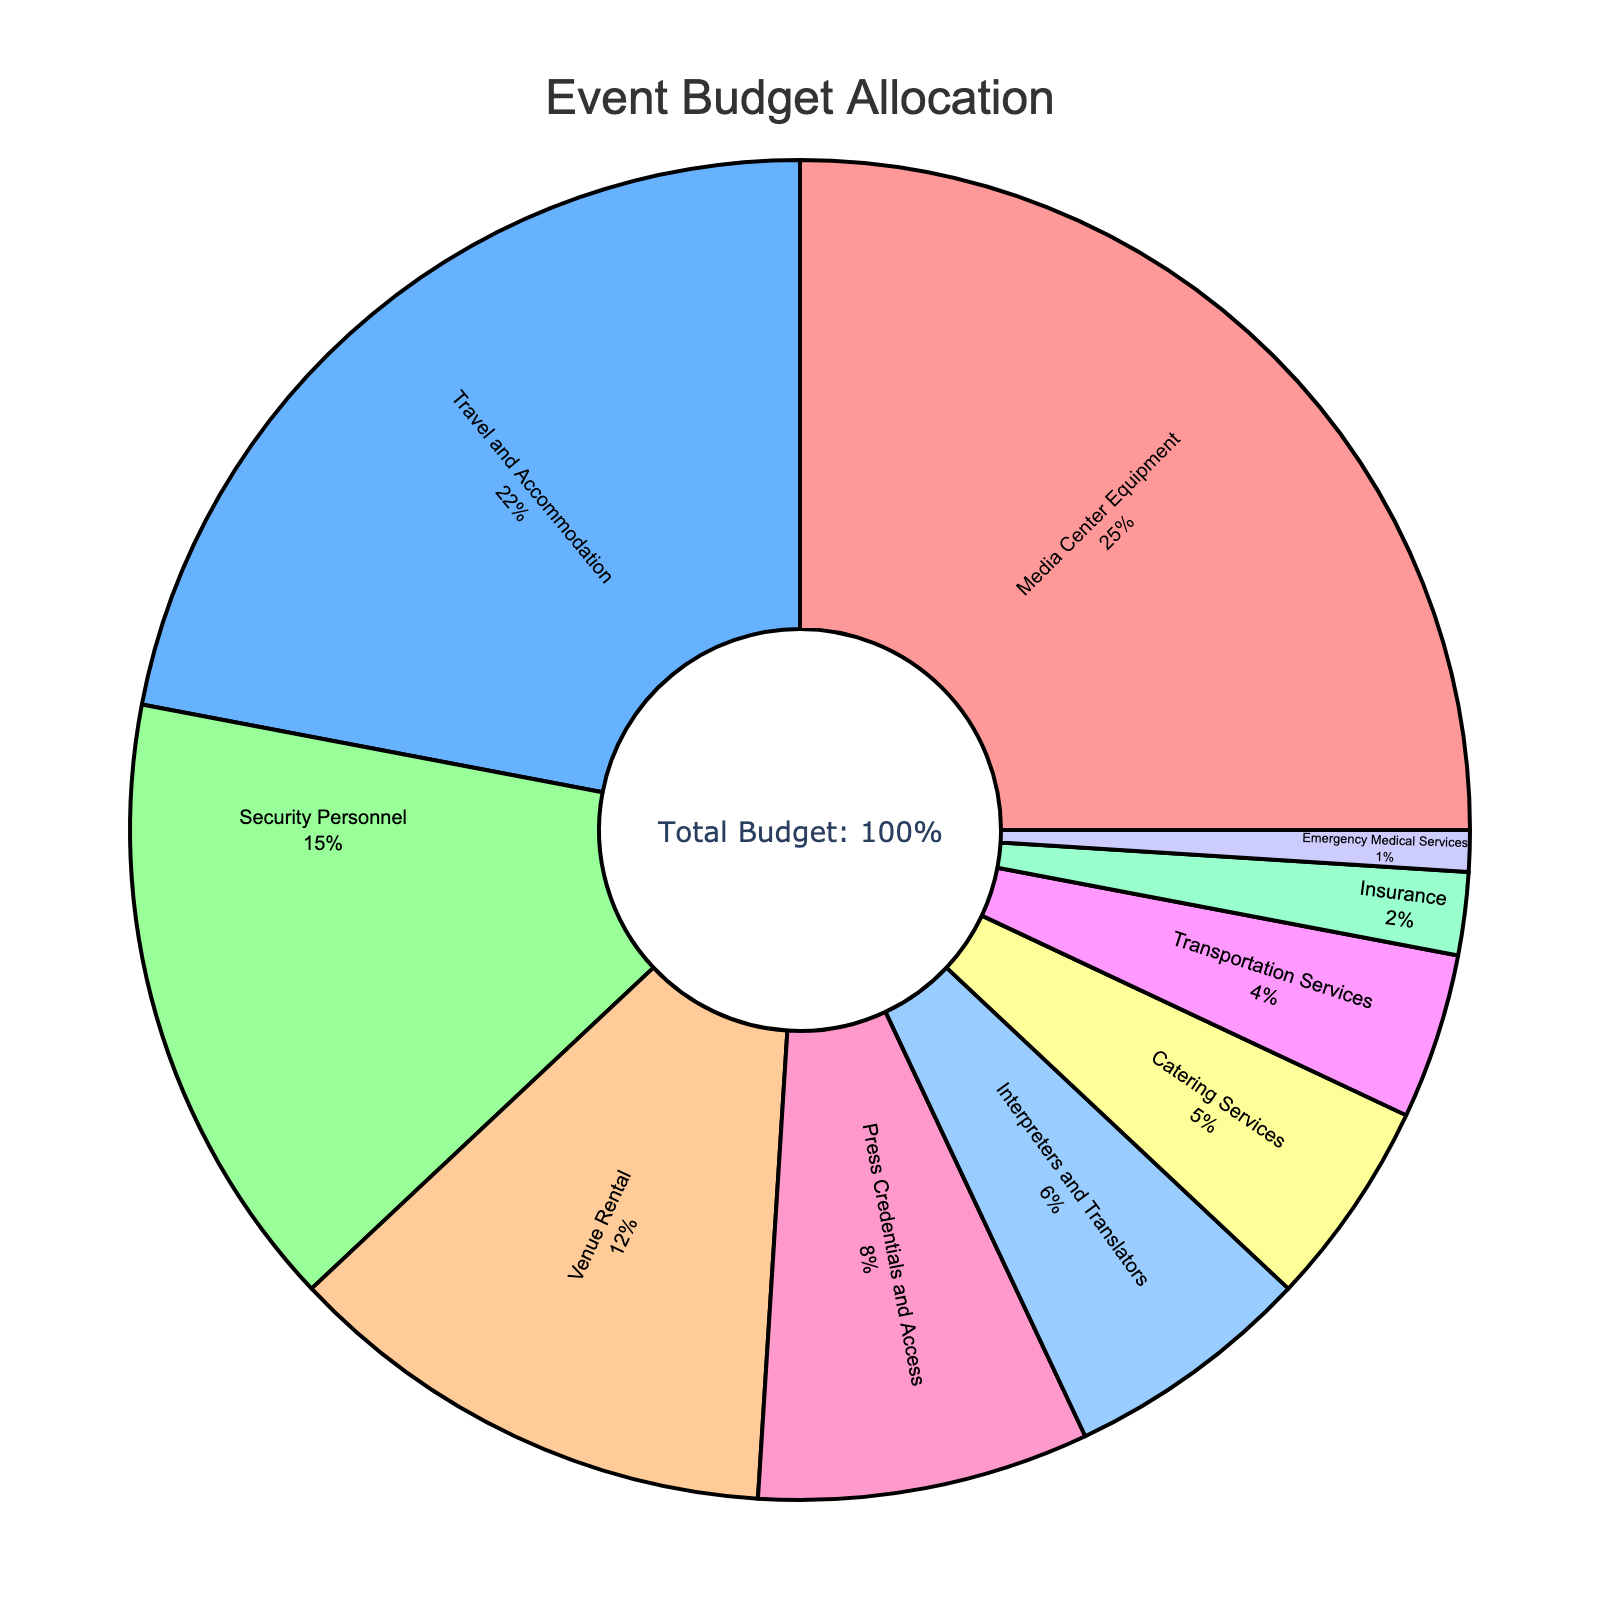What category has the largest percentage of the budget allocation? Looking at the pie chart, "Media Center Equipment" has the largest slice, which corresponds to 25% of the budget.
Answer: Media Center Equipment Which category has the smallest percentage of the budget allocation? The smallest slice on the pie chart is labeled “Emergency Medical Services,” which corresponds to 1% of the budget.
Answer: Emergency Medical Services What is the combined budget percentage for "Travel and Accommodation" and "Catering Services"? "Travel and Accommodation" takes up 22% and "Catering Services" takes up 5%. Adding these together: 22% + 5% = 27%.
Answer: 27% Is the budget for "Security Personnel" greater than the budget for "Press Credentials and Access"? The pie chart shows "Security Personnel" as 15% and "Press Credentials and Access" as 8%. 15% is greater than 8%.
Answer: Yes Which category has the closest percentage to the average of all categories? Sum all percentages (25 + 22 + 15 + 12 + 8 + 6 + 5 + 4 + 2 + 1 = 100), and divide by the number of categories (10). So, the average is 100 / 10 = 10%. The category closest to 10% is "Venue Rental" with 12%.
Answer: Venue Rental How much more is allocated to "Media Center Equipment" compared to "Travel and Accommodation"? "Media Center Equipment" is allotted 25% and "Travel and Accommodation" is allotted 22%. The difference is 25% - 22% = 3%.
Answer: 3% If the budget for "Venue Rental" were to increase by 5%, what would the new budget percentage be? "Venue Rental" is currently 12%. Increasing by 5% equals 12% + 5% = 17%.
Answer: 17% Is the sum of the percentages for "Transportation Services" and "Emergency Medical Services" less than 10%? "Transportation Services" is 4% and "Emergency Medical Services" is 1%. Adding them: 4% + 1% = 5%, which is less than 10%.
Answer: Yes How many categories have a budget allocation of less than 10%? Categories with less than 10% allocation are: “Press Credentials and Access” (8%), “Interpreters and Translators” (6%), “Catering Services” (5%), “Transportation Services” (4%), “Insurance” (2%), “Emergency Medical Services” (1%). That's 6 categories.
Answer: 6 